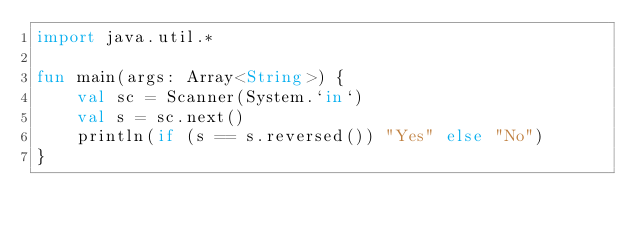<code> <loc_0><loc_0><loc_500><loc_500><_Kotlin_>import java.util.*

fun main(args: Array<String>) {
    val sc = Scanner(System.`in`)
    val s = sc.next()
    println(if (s == s.reversed()) "Yes" else "No")
}</code> 